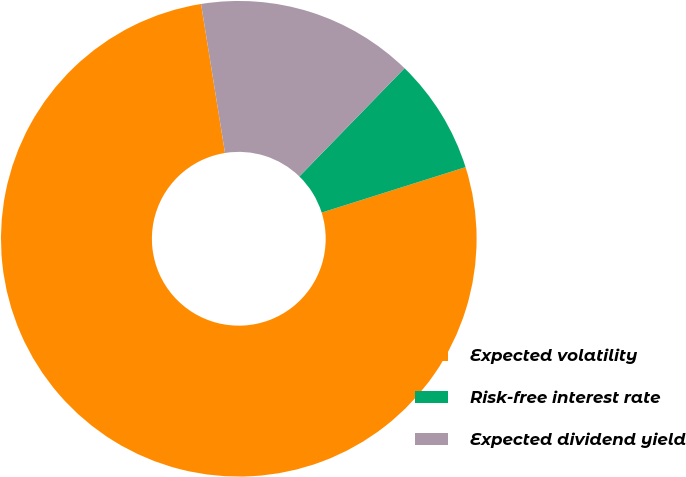Convert chart. <chart><loc_0><loc_0><loc_500><loc_500><pie_chart><fcel>Expected volatility<fcel>Risk-free interest rate<fcel>Expected dividend yield<nl><fcel>77.34%<fcel>7.86%<fcel>14.81%<nl></chart> 